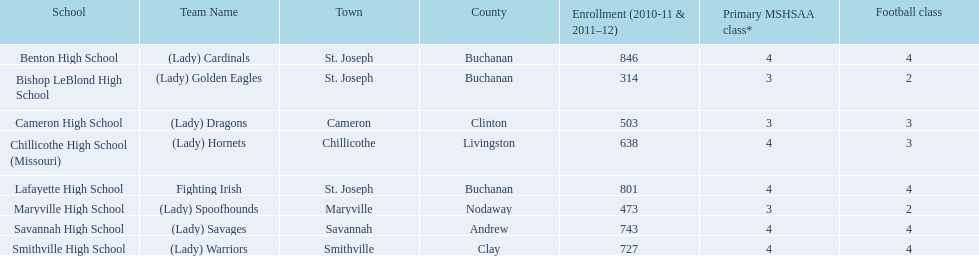Which team employs green and grey as their colors? Fighting Irish. What is this team known as? Lafayette High School. 